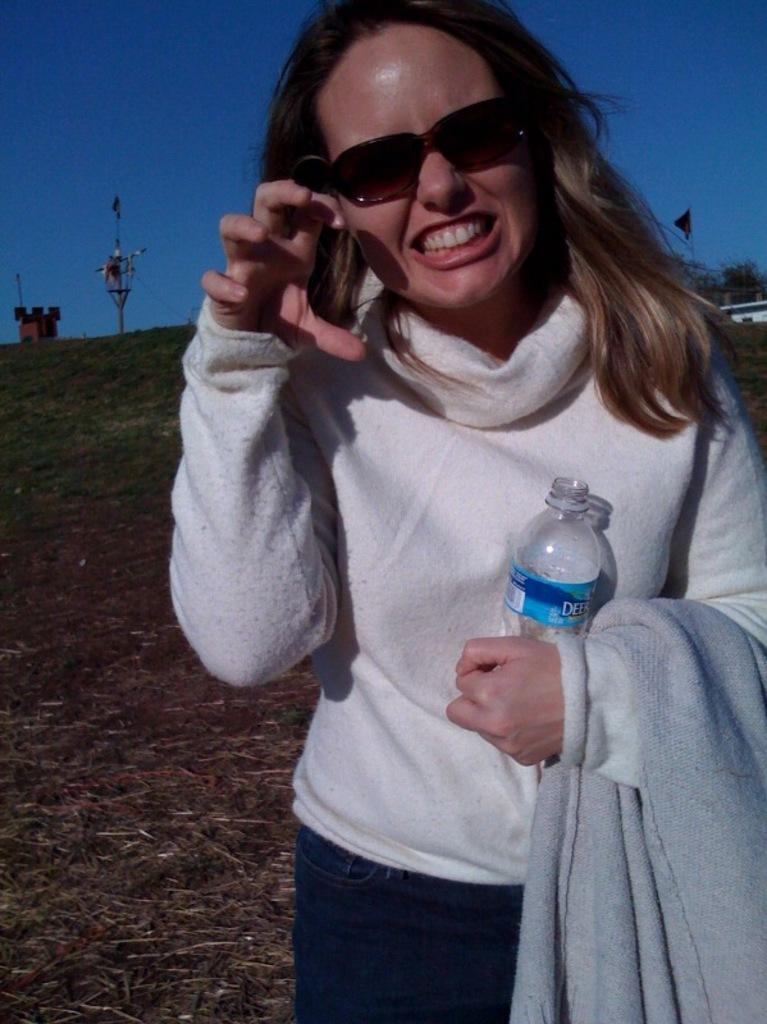What is the main subject of the image? There is a person in the image. What is the person wearing? The person is wearing a white shirt and blue pants. What is the person holding in the image? The person is holding a bottle. What can be seen in the background of the image? There are poles, green grass, and a blue sky in the background of the image. What type of canvas is the person painting on in the image? There is no canvas present in the image, nor is the person engaged in any painting activity. 